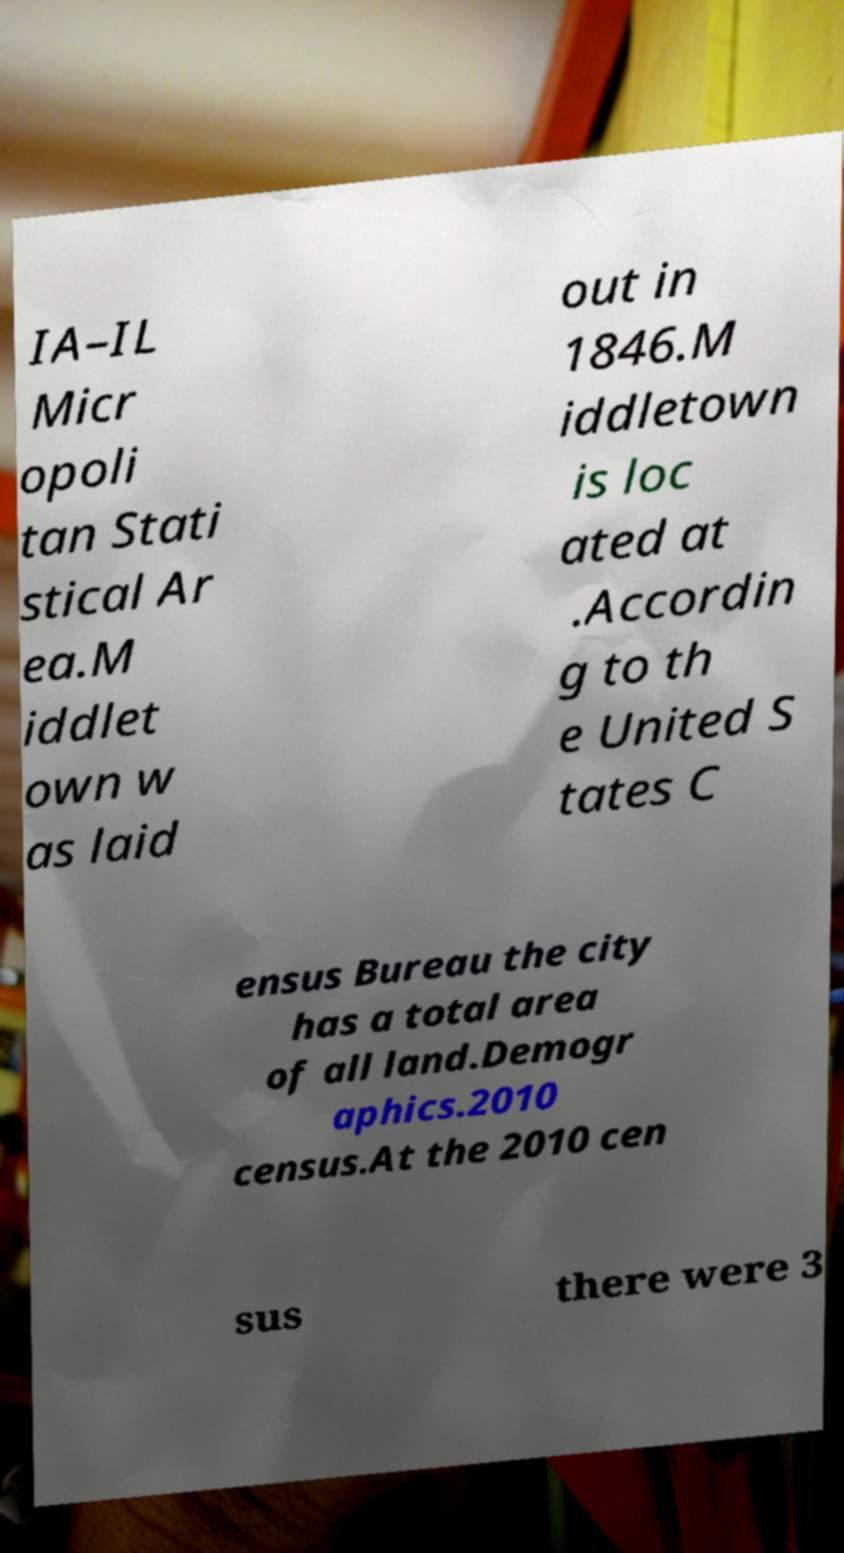Please identify and transcribe the text found in this image. IA–IL Micr opoli tan Stati stical Ar ea.M iddlet own w as laid out in 1846.M iddletown is loc ated at .Accordin g to th e United S tates C ensus Bureau the city has a total area of all land.Demogr aphics.2010 census.At the 2010 cen sus there were 3 